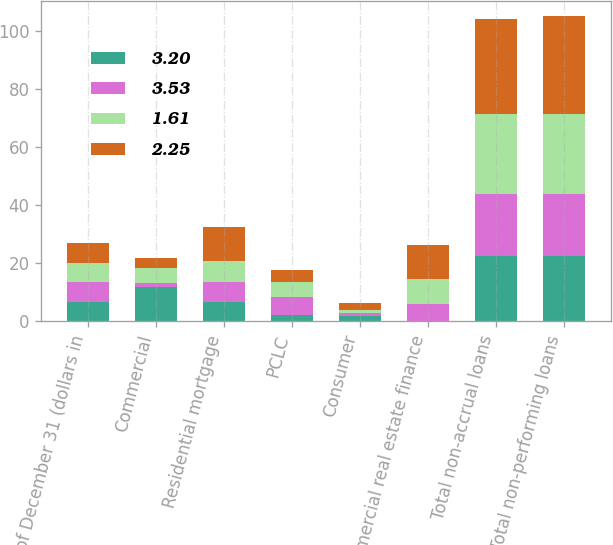Convert chart to OTSL. <chart><loc_0><loc_0><loc_500><loc_500><stacked_bar_chart><ecel><fcel>As of December 31 (dollars in<fcel>Commercial<fcel>Residential mortgage<fcel>PCLC<fcel>Consumer<fcel>Commercial real estate finance<fcel>Total non-accrual loans<fcel>Total non-performing loans<nl><fcel>3.2<fcel>6.7<fcel>11.9<fcel>6.7<fcel>2.1<fcel>1.7<fcel>0.2<fcel>22.6<fcel>22.6<nl><fcel>3.53<fcel>6.7<fcel>1.3<fcel>6.7<fcel>6.2<fcel>1.3<fcel>5.8<fcel>21.3<fcel>21.3<nl><fcel>1.61<fcel>6.7<fcel>5.2<fcel>7.5<fcel>5.1<fcel>0.9<fcel>8.7<fcel>27.4<fcel>27.4<nl><fcel>2.25<fcel>6.7<fcel>3.3<fcel>11.4<fcel>4.2<fcel>2.5<fcel>11.4<fcel>32.8<fcel>33.8<nl></chart> 